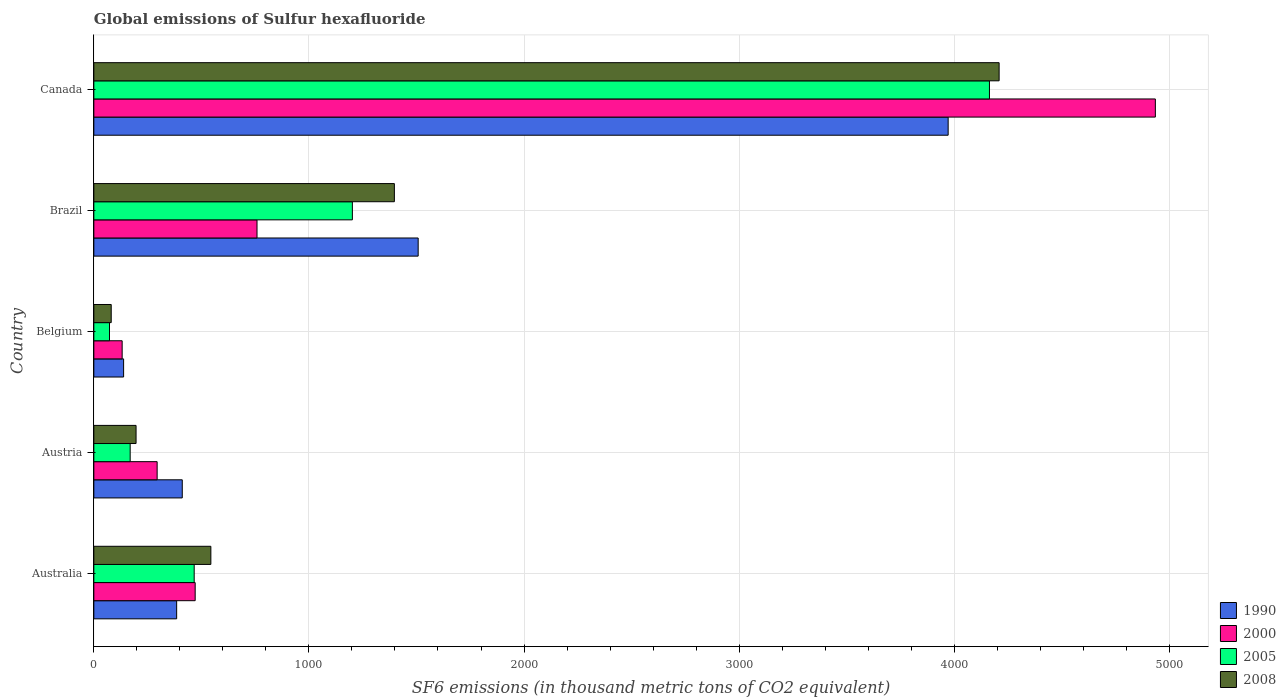Are the number of bars on each tick of the Y-axis equal?
Offer a terse response. Yes. What is the global emissions of Sulfur hexafluoride in 2008 in Brazil?
Make the answer very short. 1397.3. Across all countries, what is the maximum global emissions of Sulfur hexafluoride in 1990?
Your answer should be very brief. 3971.8. Across all countries, what is the minimum global emissions of Sulfur hexafluoride in 1990?
Give a very brief answer. 138.5. In which country was the global emissions of Sulfur hexafluoride in 2008 maximum?
Provide a short and direct response. Canada. What is the total global emissions of Sulfur hexafluoride in 2005 in the graph?
Your response must be concise. 6074.3. What is the difference between the global emissions of Sulfur hexafluoride in 2005 in Brazil and that in Canada?
Give a very brief answer. -2961.8. What is the difference between the global emissions of Sulfur hexafluoride in 2000 in Austria and the global emissions of Sulfur hexafluoride in 2005 in Australia?
Provide a succinct answer. -172.2. What is the average global emissions of Sulfur hexafluoride in 2008 per country?
Make the answer very short. 1285.5. What is the difference between the global emissions of Sulfur hexafluoride in 1990 and global emissions of Sulfur hexafluoride in 2008 in Belgium?
Provide a succinct answer. 57.6. In how many countries, is the global emissions of Sulfur hexafluoride in 2008 greater than 2400 thousand metric tons?
Provide a short and direct response. 1. What is the ratio of the global emissions of Sulfur hexafluoride in 1990 in Brazil to that in Canada?
Offer a very short reply. 0.38. What is the difference between the highest and the second highest global emissions of Sulfur hexafluoride in 2008?
Ensure brevity in your answer.  2811.5. What is the difference between the highest and the lowest global emissions of Sulfur hexafluoride in 1990?
Provide a succinct answer. 3833.3. In how many countries, is the global emissions of Sulfur hexafluoride in 2005 greater than the average global emissions of Sulfur hexafluoride in 2005 taken over all countries?
Your answer should be compact. 1. Is it the case that in every country, the sum of the global emissions of Sulfur hexafluoride in 1990 and global emissions of Sulfur hexafluoride in 2005 is greater than the sum of global emissions of Sulfur hexafluoride in 2008 and global emissions of Sulfur hexafluoride in 2000?
Give a very brief answer. No. What does the 2nd bar from the top in Austria represents?
Offer a terse response. 2005. What does the 4th bar from the bottom in Australia represents?
Keep it short and to the point. 2008. How many bars are there?
Your answer should be very brief. 20. How many countries are there in the graph?
Ensure brevity in your answer.  5. Are the values on the major ticks of X-axis written in scientific E-notation?
Your answer should be very brief. No. Does the graph contain grids?
Provide a succinct answer. Yes. How many legend labels are there?
Make the answer very short. 4. How are the legend labels stacked?
Provide a short and direct response. Vertical. What is the title of the graph?
Provide a short and direct response. Global emissions of Sulfur hexafluoride. Does "1992" appear as one of the legend labels in the graph?
Make the answer very short. No. What is the label or title of the X-axis?
Provide a succinct answer. SF6 emissions (in thousand metric tons of CO2 equivalent). What is the label or title of the Y-axis?
Your response must be concise. Country. What is the SF6 emissions (in thousand metric tons of CO2 equivalent) of 1990 in Australia?
Your response must be concise. 385.1. What is the SF6 emissions (in thousand metric tons of CO2 equivalent) of 2000 in Australia?
Offer a terse response. 471.2. What is the SF6 emissions (in thousand metric tons of CO2 equivalent) in 2005 in Australia?
Provide a short and direct response. 466.6. What is the SF6 emissions (in thousand metric tons of CO2 equivalent) of 2008 in Australia?
Make the answer very short. 544.1. What is the SF6 emissions (in thousand metric tons of CO2 equivalent) of 1990 in Austria?
Your response must be concise. 411.2. What is the SF6 emissions (in thousand metric tons of CO2 equivalent) of 2000 in Austria?
Ensure brevity in your answer.  294.4. What is the SF6 emissions (in thousand metric tons of CO2 equivalent) in 2005 in Austria?
Your response must be concise. 169. What is the SF6 emissions (in thousand metric tons of CO2 equivalent) in 2008 in Austria?
Your answer should be very brief. 196.4. What is the SF6 emissions (in thousand metric tons of CO2 equivalent) in 1990 in Belgium?
Make the answer very short. 138.5. What is the SF6 emissions (in thousand metric tons of CO2 equivalent) of 2000 in Belgium?
Ensure brevity in your answer.  131.7. What is the SF6 emissions (in thousand metric tons of CO2 equivalent) of 2005 in Belgium?
Your answer should be very brief. 72.9. What is the SF6 emissions (in thousand metric tons of CO2 equivalent) of 2008 in Belgium?
Ensure brevity in your answer.  80.9. What is the SF6 emissions (in thousand metric tons of CO2 equivalent) of 1990 in Brazil?
Provide a succinct answer. 1507.9. What is the SF6 emissions (in thousand metric tons of CO2 equivalent) of 2000 in Brazil?
Offer a terse response. 758.7. What is the SF6 emissions (in thousand metric tons of CO2 equivalent) of 2005 in Brazil?
Provide a short and direct response. 1202. What is the SF6 emissions (in thousand metric tons of CO2 equivalent) of 2008 in Brazil?
Give a very brief answer. 1397.3. What is the SF6 emissions (in thousand metric tons of CO2 equivalent) of 1990 in Canada?
Make the answer very short. 3971.8. What is the SF6 emissions (in thousand metric tons of CO2 equivalent) of 2000 in Canada?
Provide a short and direct response. 4935.1. What is the SF6 emissions (in thousand metric tons of CO2 equivalent) of 2005 in Canada?
Ensure brevity in your answer.  4163.8. What is the SF6 emissions (in thousand metric tons of CO2 equivalent) of 2008 in Canada?
Provide a succinct answer. 4208.8. Across all countries, what is the maximum SF6 emissions (in thousand metric tons of CO2 equivalent) in 1990?
Offer a very short reply. 3971.8. Across all countries, what is the maximum SF6 emissions (in thousand metric tons of CO2 equivalent) of 2000?
Offer a very short reply. 4935.1. Across all countries, what is the maximum SF6 emissions (in thousand metric tons of CO2 equivalent) in 2005?
Keep it short and to the point. 4163.8. Across all countries, what is the maximum SF6 emissions (in thousand metric tons of CO2 equivalent) in 2008?
Ensure brevity in your answer.  4208.8. Across all countries, what is the minimum SF6 emissions (in thousand metric tons of CO2 equivalent) of 1990?
Provide a short and direct response. 138.5. Across all countries, what is the minimum SF6 emissions (in thousand metric tons of CO2 equivalent) in 2000?
Make the answer very short. 131.7. Across all countries, what is the minimum SF6 emissions (in thousand metric tons of CO2 equivalent) in 2005?
Give a very brief answer. 72.9. Across all countries, what is the minimum SF6 emissions (in thousand metric tons of CO2 equivalent) in 2008?
Your answer should be very brief. 80.9. What is the total SF6 emissions (in thousand metric tons of CO2 equivalent) in 1990 in the graph?
Keep it short and to the point. 6414.5. What is the total SF6 emissions (in thousand metric tons of CO2 equivalent) of 2000 in the graph?
Your answer should be compact. 6591.1. What is the total SF6 emissions (in thousand metric tons of CO2 equivalent) in 2005 in the graph?
Your answer should be compact. 6074.3. What is the total SF6 emissions (in thousand metric tons of CO2 equivalent) of 2008 in the graph?
Your response must be concise. 6427.5. What is the difference between the SF6 emissions (in thousand metric tons of CO2 equivalent) in 1990 in Australia and that in Austria?
Your answer should be compact. -26.1. What is the difference between the SF6 emissions (in thousand metric tons of CO2 equivalent) in 2000 in Australia and that in Austria?
Provide a succinct answer. 176.8. What is the difference between the SF6 emissions (in thousand metric tons of CO2 equivalent) of 2005 in Australia and that in Austria?
Give a very brief answer. 297.6. What is the difference between the SF6 emissions (in thousand metric tons of CO2 equivalent) of 2008 in Australia and that in Austria?
Offer a very short reply. 347.7. What is the difference between the SF6 emissions (in thousand metric tons of CO2 equivalent) of 1990 in Australia and that in Belgium?
Your response must be concise. 246.6. What is the difference between the SF6 emissions (in thousand metric tons of CO2 equivalent) of 2000 in Australia and that in Belgium?
Offer a very short reply. 339.5. What is the difference between the SF6 emissions (in thousand metric tons of CO2 equivalent) of 2005 in Australia and that in Belgium?
Offer a terse response. 393.7. What is the difference between the SF6 emissions (in thousand metric tons of CO2 equivalent) in 2008 in Australia and that in Belgium?
Ensure brevity in your answer.  463.2. What is the difference between the SF6 emissions (in thousand metric tons of CO2 equivalent) in 1990 in Australia and that in Brazil?
Provide a short and direct response. -1122.8. What is the difference between the SF6 emissions (in thousand metric tons of CO2 equivalent) in 2000 in Australia and that in Brazil?
Make the answer very short. -287.5. What is the difference between the SF6 emissions (in thousand metric tons of CO2 equivalent) of 2005 in Australia and that in Brazil?
Keep it short and to the point. -735.4. What is the difference between the SF6 emissions (in thousand metric tons of CO2 equivalent) in 2008 in Australia and that in Brazil?
Provide a short and direct response. -853.2. What is the difference between the SF6 emissions (in thousand metric tons of CO2 equivalent) in 1990 in Australia and that in Canada?
Your response must be concise. -3586.7. What is the difference between the SF6 emissions (in thousand metric tons of CO2 equivalent) of 2000 in Australia and that in Canada?
Provide a short and direct response. -4463.9. What is the difference between the SF6 emissions (in thousand metric tons of CO2 equivalent) in 2005 in Australia and that in Canada?
Provide a succinct answer. -3697.2. What is the difference between the SF6 emissions (in thousand metric tons of CO2 equivalent) in 2008 in Australia and that in Canada?
Ensure brevity in your answer.  -3664.7. What is the difference between the SF6 emissions (in thousand metric tons of CO2 equivalent) of 1990 in Austria and that in Belgium?
Your response must be concise. 272.7. What is the difference between the SF6 emissions (in thousand metric tons of CO2 equivalent) in 2000 in Austria and that in Belgium?
Your response must be concise. 162.7. What is the difference between the SF6 emissions (in thousand metric tons of CO2 equivalent) in 2005 in Austria and that in Belgium?
Your answer should be compact. 96.1. What is the difference between the SF6 emissions (in thousand metric tons of CO2 equivalent) in 2008 in Austria and that in Belgium?
Keep it short and to the point. 115.5. What is the difference between the SF6 emissions (in thousand metric tons of CO2 equivalent) of 1990 in Austria and that in Brazil?
Your answer should be compact. -1096.7. What is the difference between the SF6 emissions (in thousand metric tons of CO2 equivalent) in 2000 in Austria and that in Brazil?
Provide a short and direct response. -464.3. What is the difference between the SF6 emissions (in thousand metric tons of CO2 equivalent) of 2005 in Austria and that in Brazil?
Give a very brief answer. -1033. What is the difference between the SF6 emissions (in thousand metric tons of CO2 equivalent) in 2008 in Austria and that in Brazil?
Offer a very short reply. -1200.9. What is the difference between the SF6 emissions (in thousand metric tons of CO2 equivalent) of 1990 in Austria and that in Canada?
Offer a very short reply. -3560.6. What is the difference between the SF6 emissions (in thousand metric tons of CO2 equivalent) in 2000 in Austria and that in Canada?
Give a very brief answer. -4640.7. What is the difference between the SF6 emissions (in thousand metric tons of CO2 equivalent) in 2005 in Austria and that in Canada?
Offer a very short reply. -3994.8. What is the difference between the SF6 emissions (in thousand metric tons of CO2 equivalent) in 2008 in Austria and that in Canada?
Your answer should be very brief. -4012.4. What is the difference between the SF6 emissions (in thousand metric tons of CO2 equivalent) in 1990 in Belgium and that in Brazil?
Offer a terse response. -1369.4. What is the difference between the SF6 emissions (in thousand metric tons of CO2 equivalent) in 2000 in Belgium and that in Brazil?
Your answer should be compact. -627. What is the difference between the SF6 emissions (in thousand metric tons of CO2 equivalent) of 2005 in Belgium and that in Brazil?
Provide a succinct answer. -1129.1. What is the difference between the SF6 emissions (in thousand metric tons of CO2 equivalent) of 2008 in Belgium and that in Brazil?
Your answer should be very brief. -1316.4. What is the difference between the SF6 emissions (in thousand metric tons of CO2 equivalent) in 1990 in Belgium and that in Canada?
Provide a short and direct response. -3833.3. What is the difference between the SF6 emissions (in thousand metric tons of CO2 equivalent) in 2000 in Belgium and that in Canada?
Offer a very short reply. -4803.4. What is the difference between the SF6 emissions (in thousand metric tons of CO2 equivalent) in 2005 in Belgium and that in Canada?
Offer a very short reply. -4090.9. What is the difference between the SF6 emissions (in thousand metric tons of CO2 equivalent) of 2008 in Belgium and that in Canada?
Your answer should be very brief. -4127.9. What is the difference between the SF6 emissions (in thousand metric tons of CO2 equivalent) in 1990 in Brazil and that in Canada?
Provide a succinct answer. -2463.9. What is the difference between the SF6 emissions (in thousand metric tons of CO2 equivalent) in 2000 in Brazil and that in Canada?
Your answer should be very brief. -4176.4. What is the difference between the SF6 emissions (in thousand metric tons of CO2 equivalent) in 2005 in Brazil and that in Canada?
Keep it short and to the point. -2961.8. What is the difference between the SF6 emissions (in thousand metric tons of CO2 equivalent) of 2008 in Brazil and that in Canada?
Your answer should be very brief. -2811.5. What is the difference between the SF6 emissions (in thousand metric tons of CO2 equivalent) of 1990 in Australia and the SF6 emissions (in thousand metric tons of CO2 equivalent) of 2000 in Austria?
Offer a terse response. 90.7. What is the difference between the SF6 emissions (in thousand metric tons of CO2 equivalent) in 1990 in Australia and the SF6 emissions (in thousand metric tons of CO2 equivalent) in 2005 in Austria?
Your answer should be very brief. 216.1. What is the difference between the SF6 emissions (in thousand metric tons of CO2 equivalent) of 1990 in Australia and the SF6 emissions (in thousand metric tons of CO2 equivalent) of 2008 in Austria?
Make the answer very short. 188.7. What is the difference between the SF6 emissions (in thousand metric tons of CO2 equivalent) in 2000 in Australia and the SF6 emissions (in thousand metric tons of CO2 equivalent) in 2005 in Austria?
Provide a short and direct response. 302.2. What is the difference between the SF6 emissions (in thousand metric tons of CO2 equivalent) in 2000 in Australia and the SF6 emissions (in thousand metric tons of CO2 equivalent) in 2008 in Austria?
Keep it short and to the point. 274.8. What is the difference between the SF6 emissions (in thousand metric tons of CO2 equivalent) of 2005 in Australia and the SF6 emissions (in thousand metric tons of CO2 equivalent) of 2008 in Austria?
Offer a very short reply. 270.2. What is the difference between the SF6 emissions (in thousand metric tons of CO2 equivalent) in 1990 in Australia and the SF6 emissions (in thousand metric tons of CO2 equivalent) in 2000 in Belgium?
Offer a terse response. 253.4. What is the difference between the SF6 emissions (in thousand metric tons of CO2 equivalent) of 1990 in Australia and the SF6 emissions (in thousand metric tons of CO2 equivalent) of 2005 in Belgium?
Your answer should be compact. 312.2. What is the difference between the SF6 emissions (in thousand metric tons of CO2 equivalent) in 1990 in Australia and the SF6 emissions (in thousand metric tons of CO2 equivalent) in 2008 in Belgium?
Your response must be concise. 304.2. What is the difference between the SF6 emissions (in thousand metric tons of CO2 equivalent) of 2000 in Australia and the SF6 emissions (in thousand metric tons of CO2 equivalent) of 2005 in Belgium?
Your answer should be compact. 398.3. What is the difference between the SF6 emissions (in thousand metric tons of CO2 equivalent) of 2000 in Australia and the SF6 emissions (in thousand metric tons of CO2 equivalent) of 2008 in Belgium?
Your answer should be very brief. 390.3. What is the difference between the SF6 emissions (in thousand metric tons of CO2 equivalent) of 2005 in Australia and the SF6 emissions (in thousand metric tons of CO2 equivalent) of 2008 in Belgium?
Provide a succinct answer. 385.7. What is the difference between the SF6 emissions (in thousand metric tons of CO2 equivalent) in 1990 in Australia and the SF6 emissions (in thousand metric tons of CO2 equivalent) in 2000 in Brazil?
Make the answer very short. -373.6. What is the difference between the SF6 emissions (in thousand metric tons of CO2 equivalent) of 1990 in Australia and the SF6 emissions (in thousand metric tons of CO2 equivalent) of 2005 in Brazil?
Offer a terse response. -816.9. What is the difference between the SF6 emissions (in thousand metric tons of CO2 equivalent) of 1990 in Australia and the SF6 emissions (in thousand metric tons of CO2 equivalent) of 2008 in Brazil?
Your response must be concise. -1012.2. What is the difference between the SF6 emissions (in thousand metric tons of CO2 equivalent) of 2000 in Australia and the SF6 emissions (in thousand metric tons of CO2 equivalent) of 2005 in Brazil?
Provide a short and direct response. -730.8. What is the difference between the SF6 emissions (in thousand metric tons of CO2 equivalent) in 2000 in Australia and the SF6 emissions (in thousand metric tons of CO2 equivalent) in 2008 in Brazil?
Make the answer very short. -926.1. What is the difference between the SF6 emissions (in thousand metric tons of CO2 equivalent) in 2005 in Australia and the SF6 emissions (in thousand metric tons of CO2 equivalent) in 2008 in Brazil?
Your answer should be compact. -930.7. What is the difference between the SF6 emissions (in thousand metric tons of CO2 equivalent) of 1990 in Australia and the SF6 emissions (in thousand metric tons of CO2 equivalent) of 2000 in Canada?
Make the answer very short. -4550. What is the difference between the SF6 emissions (in thousand metric tons of CO2 equivalent) in 1990 in Australia and the SF6 emissions (in thousand metric tons of CO2 equivalent) in 2005 in Canada?
Ensure brevity in your answer.  -3778.7. What is the difference between the SF6 emissions (in thousand metric tons of CO2 equivalent) in 1990 in Australia and the SF6 emissions (in thousand metric tons of CO2 equivalent) in 2008 in Canada?
Give a very brief answer. -3823.7. What is the difference between the SF6 emissions (in thousand metric tons of CO2 equivalent) in 2000 in Australia and the SF6 emissions (in thousand metric tons of CO2 equivalent) in 2005 in Canada?
Offer a very short reply. -3692.6. What is the difference between the SF6 emissions (in thousand metric tons of CO2 equivalent) in 2000 in Australia and the SF6 emissions (in thousand metric tons of CO2 equivalent) in 2008 in Canada?
Keep it short and to the point. -3737.6. What is the difference between the SF6 emissions (in thousand metric tons of CO2 equivalent) of 2005 in Australia and the SF6 emissions (in thousand metric tons of CO2 equivalent) of 2008 in Canada?
Your answer should be very brief. -3742.2. What is the difference between the SF6 emissions (in thousand metric tons of CO2 equivalent) in 1990 in Austria and the SF6 emissions (in thousand metric tons of CO2 equivalent) in 2000 in Belgium?
Offer a terse response. 279.5. What is the difference between the SF6 emissions (in thousand metric tons of CO2 equivalent) of 1990 in Austria and the SF6 emissions (in thousand metric tons of CO2 equivalent) of 2005 in Belgium?
Offer a terse response. 338.3. What is the difference between the SF6 emissions (in thousand metric tons of CO2 equivalent) in 1990 in Austria and the SF6 emissions (in thousand metric tons of CO2 equivalent) in 2008 in Belgium?
Offer a terse response. 330.3. What is the difference between the SF6 emissions (in thousand metric tons of CO2 equivalent) of 2000 in Austria and the SF6 emissions (in thousand metric tons of CO2 equivalent) of 2005 in Belgium?
Your answer should be very brief. 221.5. What is the difference between the SF6 emissions (in thousand metric tons of CO2 equivalent) of 2000 in Austria and the SF6 emissions (in thousand metric tons of CO2 equivalent) of 2008 in Belgium?
Make the answer very short. 213.5. What is the difference between the SF6 emissions (in thousand metric tons of CO2 equivalent) in 2005 in Austria and the SF6 emissions (in thousand metric tons of CO2 equivalent) in 2008 in Belgium?
Your answer should be very brief. 88.1. What is the difference between the SF6 emissions (in thousand metric tons of CO2 equivalent) in 1990 in Austria and the SF6 emissions (in thousand metric tons of CO2 equivalent) in 2000 in Brazil?
Ensure brevity in your answer.  -347.5. What is the difference between the SF6 emissions (in thousand metric tons of CO2 equivalent) in 1990 in Austria and the SF6 emissions (in thousand metric tons of CO2 equivalent) in 2005 in Brazil?
Your answer should be compact. -790.8. What is the difference between the SF6 emissions (in thousand metric tons of CO2 equivalent) of 1990 in Austria and the SF6 emissions (in thousand metric tons of CO2 equivalent) of 2008 in Brazil?
Ensure brevity in your answer.  -986.1. What is the difference between the SF6 emissions (in thousand metric tons of CO2 equivalent) in 2000 in Austria and the SF6 emissions (in thousand metric tons of CO2 equivalent) in 2005 in Brazil?
Offer a very short reply. -907.6. What is the difference between the SF6 emissions (in thousand metric tons of CO2 equivalent) of 2000 in Austria and the SF6 emissions (in thousand metric tons of CO2 equivalent) of 2008 in Brazil?
Provide a short and direct response. -1102.9. What is the difference between the SF6 emissions (in thousand metric tons of CO2 equivalent) of 2005 in Austria and the SF6 emissions (in thousand metric tons of CO2 equivalent) of 2008 in Brazil?
Provide a succinct answer. -1228.3. What is the difference between the SF6 emissions (in thousand metric tons of CO2 equivalent) in 1990 in Austria and the SF6 emissions (in thousand metric tons of CO2 equivalent) in 2000 in Canada?
Give a very brief answer. -4523.9. What is the difference between the SF6 emissions (in thousand metric tons of CO2 equivalent) of 1990 in Austria and the SF6 emissions (in thousand metric tons of CO2 equivalent) of 2005 in Canada?
Your answer should be compact. -3752.6. What is the difference between the SF6 emissions (in thousand metric tons of CO2 equivalent) in 1990 in Austria and the SF6 emissions (in thousand metric tons of CO2 equivalent) in 2008 in Canada?
Provide a succinct answer. -3797.6. What is the difference between the SF6 emissions (in thousand metric tons of CO2 equivalent) of 2000 in Austria and the SF6 emissions (in thousand metric tons of CO2 equivalent) of 2005 in Canada?
Make the answer very short. -3869.4. What is the difference between the SF6 emissions (in thousand metric tons of CO2 equivalent) in 2000 in Austria and the SF6 emissions (in thousand metric tons of CO2 equivalent) in 2008 in Canada?
Give a very brief answer. -3914.4. What is the difference between the SF6 emissions (in thousand metric tons of CO2 equivalent) in 2005 in Austria and the SF6 emissions (in thousand metric tons of CO2 equivalent) in 2008 in Canada?
Keep it short and to the point. -4039.8. What is the difference between the SF6 emissions (in thousand metric tons of CO2 equivalent) of 1990 in Belgium and the SF6 emissions (in thousand metric tons of CO2 equivalent) of 2000 in Brazil?
Provide a succinct answer. -620.2. What is the difference between the SF6 emissions (in thousand metric tons of CO2 equivalent) in 1990 in Belgium and the SF6 emissions (in thousand metric tons of CO2 equivalent) in 2005 in Brazil?
Provide a short and direct response. -1063.5. What is the difference between the SF6 emissions (in thousand metric tons of CO2 equivalent) in 1990 in Belgium and the SF6 emissions (in thousand metric tons of CO2 equivalent) in 2008 in Brazil?
Make the answer very short. -1258.8. What is the difference between the SF6 emissions (in thousand metric tons of CO2 equivalent) in 2000 in Belgium and the SF6 emissions (in thousand metric tons of CO2 equivalent) in 2005 in Brazil?
Provide a short and direct response. -1070.3. What is the difference between the SF6 emissions (in thousand metric tons of CO2 equivalent) of 2000 in Belgium and the SF6 emissions (in thousand metric tons of CO2 equivalent) of 2008 in Brazil?
Ensure brevity in your answer.  -1265.6. What is the difference between the SF6 emissions (in thousand metric tons of CO2 equivalent) in 2005 in Belgium and the SF6 emissions (in thousand metric tons of CO2 equivalent) in 2008 in Brazil?
Provide a succinct answer. -1324.4. What is the difference between the SF6 emissions (in thousand metric tons of CO2 equivalent) in 1990 in Belgium and the SF6 emissions (in thousand metric tons of CO2 equivalent) in 2000 in Canada?
Give a very brief answer. -4796.6. What is the difference between the SF6 emissions (in thousand metric tons of CO2 equivalent) of 1990 in Belgium and the SF6 emissions (in thousand metric tons of CO2 equivalent) of 2005 in Canada?
Your answer should be compact. -4025.3. What is the difference between the SF6 emissions (in thousand metric tons of CO2 equivalent) of 1990 in Belgium and the SF6 emissions (in thousand metric tons of CO2 equivalent) of 2008 in Canada?
Your answer should be very brief. -4070.3. What is the difference between the SF6 emissions (in thousand metric tons of CO2 equivalent) in 2000 in Belgium and the SF6 emissions (in thousand metric tons of CO2 equivalent) in 2005 in Canada?
Give a very brief answer. -4032.1. What is the difference between the SF6 emissions (in thousand metric tons of CO2 equivalent) of 2000 in Belgium and the SF6 emissions (in thousand metric tons of CO2 equivalent) of 2008 in Canada?
Provide a short and direct response. -4077.1. What is the difference between the SF6 emissions (in thousand metric tons of CO2 equivalent) in 2005 in Belgium and the SF6 emissions (in thousand metric tons of CO2 equivalent) in 2008 in Canada?
Give a very brief answer. -4135.9. What is the difference between the SF6 emissions (in thousand metric tons of CO2 equivalent) in 1990 in Brazil and the SF6 emissions (in thousand metric tons of CO2 equivalent) in 2000 in Canada?
Offer a very short reply. -3427.2. What is the difference between the SF6 emissions (in thousand metric tons of CO2 equivalent) of 1990 in Brazil and the SF6 emissions (in thousand metric tons of CO2 equivalent) of 2005 in Canada?
Offer a very short reply. -2655.9. What is the difference between the SF6 emissions (in thousand metric tons of CO2 equivalent) of 1990 in Brazil and the SF6 emissions (in thousand metric tons of CO2 equivalent) of 2008 in Canada?
Make the answer very short. -2700.9. What is the difference between the SF6 emissions (in thousand metric tons of CO2 equivalent) in 2000 in Brazil and the SF6 emissions (in thousand metric tons of CO2 equivalent) in 2005 in Canada?
Offer a very short reply. -3405.1. What is the difference between the SF6 emissions (in thousand metric tons of CO2 equivalent) of 2000 in Brazil and the SF6 emissions (in thousand metric tons of CO2 equivalent) of 2008 in Canada?
Offer a terse response. -3450.1. What is the difference between the SF6 emissions (in thousand metric tons of CO2 equivalent) in 2005 in Brazil and the SF6 emissions (in thousand metric tons of CO2 equivalent) in 2008 in Canada?
Offer a very short reply. -3006.8. What is the average SF6 emissions (in thousand metric tons of CO2 equivalent) of 1990 per country?
Provide a short and direct response. 1282.9. What is the average SF6 emissions (in thousand metric tons of CO2 equivalent) in 2000 per country?
Your answer should be very brief. 1318.22. What is the average SF6 emissions (in thousand metric tons of CO2 equivalent) of 2005 per country?
Ensure brevity in your answer.  1214.86. What is the average SF6 emissions (in thousand metric tons of CO2 equivalent) of 2008 per country?
Provide a succinct answer. 1285.5. What is the difference between the SF6 emissions (in thousand metric tons of CO2 equivalent) of 1990 and SF6 emissions (in thousand metric tons of CO2 equivalent) of 2000 in Australia?
Ensure brevity in your answer.  -86.1. What is the difference between the SF6 emissions (in thousand metric tons of CO2 equivalent) of 1990 and SF6 emissions (in thousand metric tons of CO2 equivalent) of 2005 in Australia?
Keep it short and to the point. -81.5. What is the difference between the SF6 emissions (in thousand metric tons of CO2 equivalent) in 1990 and SF6 emissions (in thousand metric tons of CO2 equivalent) in 2008 in Australia?
Offer a terse response. -159. What is the difference between the SF6 emissions (in thousand metric tons of CO2 equivalent) of 2000 and SF6 emissions (in thousand metric tons of CO2 equivalent) of 2005 in Australia?
Your answer should be compact. 4.6. What is the difference between the SF6 emissions (in thousand metric tons of CO2 equivalent) of 2000 and SF6 emissions (in thousand metric tons of CO2 equivalent) of 2008 in Australia?
Give a very brief answer. -72.9. What is the difference between the SF6 emissions (in thousand metric tons of CO2 equivalent) of 2005 and SF6 emissions (in thousand metric tons of CO2 equivalent) of 2008 in Australia?
Ensure brevity in your answer.  -77.5. What is the difference between the SF6 emissions (in thousand metric tons of CO2 equivalent) of 1990 and SF6 emissions (in thousand metric tons of CO2 equivalent) of 2000 in Austria?
Your answer should be compact. 116.8. What is the difference between the SF6 emissions (in thousand metric tons of CO2 equivalent) in 1990 and SF6 emissions (in thousand metric tons of CO2 equivalent) in 2005 in Austria?
Your answer should be compact. 242.2. What is the difference between the SF6 emissions (in thousand metric tons of CO2 equivalent) in 1990 and SF6 emissions (in thousand metric tons of CO2 equivalent) in 2008 in Austria?
Your answer should be compact. 214.8. What is the difference between the SF6 emissions (in thousand metric tons of CO2 equivalent) in 2000 and SF6 emissions (in thousand metric tons of CO2 equivalent) in 2005 in Austria?
Offer a very short reply. 125.4. What is the difference between the SF6 emissions (in thousand metric tons of CO2 equivalent) of 2000 and SF6 emissions (in thousand metric tons of CO2 equivalent) of 2008 in Austria?
Your response must be concise. 98. What is the difference between the SF6 emissions (in thousand metric tons of CO2 equivalent) of 2005 and SF6 emissions (in thousand metric tons of CO2 equivalent) of 2008 in Austria?
Provide a succinct answer. -27.4. What is the difference between the SF6 emissions (in thousand metric tons of CO2 equivalent) in 1990 and SF6 emissions (in thousand metric tons of CO2 equivalent) in 2000 in Belgium?
Offer a very short reply. 6.8. What is the difference between the SF6 emissions (in thousand metric tons of CO2 equivalent) of 1990 and SF6 emissions (in thousand metric tons of CO2 equivalent) of 2005 in Belgium?
Your answer should be compact. 65.6. What is the difference between the SF6 emissions (in thousand metric tons of CO2 equivalent) of 1990 and SF6 emissions (in thousand metric tons of CO2 equivalent) of 2008 in Belgium?
Your response must be concise. 57.6. What is the difference between the SF6 emissions (in thousand metric tons of CO2 equivalent) in 2000 and SF6 emissions (in thousand metric tons of CO2 equivalent) in 2005 in Belgium?
Your answer should be very brief. 58.8. What is the difference between the SF6 emissions (in thousand metric tons of CO2 equivalent) in 2000 and SF6 emissions (in thousand metric tons of CO2 equivalent) in 2008 in Belgium?
Your answer should be compact. 50.8. What is the difference between the SF6 emissions (in thousand metric tons of CO2 equivalent) of 2005 and SF6 emissions (in thousand metric tons of CO2 equivalent) of 2008 in Belgium?
Provide a succinct answer. -8. What is the difference between the SF6 emissions (in thousand metric tons of CO2 equivalent) in 1990 and SF6 emissions (in thousand metric tons of CO2 equivalent) in 2000 in Brazil?
Offer a terse response. 749.2. What is the difference between the SF6 emissions (in thousand metric tons of CO2 equivalent) of 1990 and SF6 emissions (in thousand metric tons of CO2 equivalent) of 2005 in Brazil?
Your response must be concise. 305.9. What is the difference between the SF6 emissions (in thousand metric tons of CO2 equivalent) of 1990 and SF6 emissions (in thousand metric tons of CO2 equivalent) of 2008 in Brazil?
Give a very brief answer. 110.6. What is the difference between the SF6 emissions (in thousand metric tons of CO2 equivalent) in 2000 and SF6 emissions (in thousand metric tons of CO2 equivalent) in 2005 in Brazil?
Your answer should be very brief. -443.3. What is the difference between the SF6 emissions (in thousand metric tons of CO2 equivalent) in 2000 and SF6 emissions (in thousand metric tons of CO2 equivalent) in 2008 in Brazil?
Offer a very short reply. -638.6. What is the difference between the SF6 emissions (in thousand metric tons of CO2 equivalent) in 2005 and SF6 emissions (in thousand metric tons of CO2 equivalent) in 2008 in Brazil?
Provide a short and direct response. -195.3. What is the difference between the SF6 emissions (in thousand metric tons of CO2 equivalent) of 1990 and SF6 emissions (in thousand metric tons of CO2 equivalent) of 2000 in Canada?
Ensure brevity in your answer.  -963.3. What is the difference between the SF6 emissions (in thousand metric tons of CO2 equivalent) in 1990 and SF6 emissions (in thousand metric tons of CO2 equivalent) in 2005 in Canada?
Offer a very short reply. -192. What is the difference between the SF6 emissions (in thousand metric tons of CO2 equivalent) of 1990 and SF6 emissions (in thousand metric tons of CO2 equivalent) of 2008 in Canada?
Provide a succinct answer. -237. What is the difference between the SF6 emissions (in thousand metric tons of CO2 equivalent) in 2000 and SF6 emissions (in thousand metric tons of CO2 equivalent) in 2005 in Canada?
Keep it short and to the point. 771.3. What is the difference between the SF6 emissions (in thousand metric tons of CO2 equivalent) of 2000 and SF6 emissions (in thousand metric tons of CO2 equivalent) of 2008 in Canada?
Keep it short and to the point. 726.3. What is the difference between the SF6 emissions (in thousand metric tons of CO2 equivalent) of 2005 and SF6 emissions (in thousand metric tons of CO2 equivalent) of 2008 in Canada?
Keep it short and to the point. -45. What is the ratio of the SF6 emissions (in thousand metric tons of CO2 equivalent) in 1990 in Australia to that in Austria?
Offer a very short reply. 0.94. What is the ratio of the SF6 emissions (in thousand metric tons of CO2 equivalent) in 2000 in Australia to that in Austria?
Ensure brevity in your answer.  1.6. What is the ratio of the SF6 emissions (in thousand metric tons of CO2 equivalent) in 2005 in Australia to that in Austria?
Your answer should be compact. 2.76. What is the ratio of the SF6 emissions (in thousand metric tons of CO2 equivalent) of 2008 in Australia to that in Austria?
Provide a succinct answer. 2.77. What is the ratio of the SF6 emissions (in thousand metric tons of CO2 equivalent) of 1990 in Australia to that in Belgium?
Ensure brevity in your answer.  2.78. What is the ratio of the SF6 emissions (in thousand metric tons of CO2 equivalent) in 2000 in Australia to that in Belgium?
Your answer should be very brief. 3.58. What is the ratio of the SF6 emissions (in thousand metric tons of CO2 equivalent) in 2005 in Australia to that in Belgium?
Provide a succinct answer. 6.4. What is the ratio of the SF6 emissions (in thousand metric tons of CO2 equivalent) of 2008 in Australia to that in Belgium?
Make the answer very short. 6.73. What is the ratio of the SF6 emissions (in thousand metric tons of CO2 equivalent) of 1990 in Australia to that in Brazil?
Ensure brevity in your answer.  0.26. What is the ratio of the SF6 emissions (in thousand metric tons of CO2 equivalent) in 2000 in Australia to that in Brazil?
Provide a short and direct response. 0.62. What is the ratio of the SF6 emissions (in thousand metric tons of CO2 equivalent) in 2005 in Australia to that in Brazil?
Offer a terse response. 0.39. What is the ratio of the SF6 emissions (in thousand metric tons of CO2 equivalent) of 2008 in Australia to that in Brazil?
Your answer should be very brief. 0.39. What is the ratio of the SF6 emissions (in thousand metric tons of CO2 equivalent) of 1990 in Australia to that in Canada?
Keep it short and to the point. 0.1. What is the ratio of the SF6 emissions (in thousand metric tons of CO2 equivalent) in 2000 in Australia to that in Canada?
Your answer should be very brief. 0.1. What is the ratio of the SF6 emissions (in thousand metric tons of CO2 equivalent) of 2005 in Australia to that in Canada?
Your answer should be compact. 0.11. What is the ratio of the SF6 emissions (in thousand metric tons of CO2 equivalent) of 2008 in Australia to that in Canada?
Provide a succinct answer. 0.13. What is the ratio of the SF6 emissions (in thousand metric tons of CO2 equivalent) in 1990 in Austria to that in Belgium?
Make the answer very short. 2.97. What is the ratio of the SF6 emissions (in thousand metric tons of CO2 equivalent) of 2000 in Austria to that in Belgium?
Your answer should be compact. 2.24. What is the ratio of the SF6 emissions (in thousand metric tons of CO2 equivalent) of 2005 in Austria to that in Belgium?
Your answer should be compact. 2.32. What is the ratio of the SF6 emissions (in thousand metric tons of CO2 equivalent) in 2008 in Austria to that in Belgium?
Provide a succinct answer. 2.43. What is the ratio of the SF6 emissions (in thousand metric tons of CO2 equivalent) of 1990 in Austria to that in Brazil?
Your answer should be compact. 0.27. What is the ratio of the SF6 emissions (in thousand metric tons of CO2 equivalent) in 2000 in Austria to that in Brazil?
Provide a succinct answer. 0.39. What is the ratio of the SF6 emissions (in thousand metric tons of CO2 equivalent) in 2005 in Austria to that in Brazil?
Provide a succinct answer. 0.14. What is the ratio of the SF6 emissions (in thousand metric tons of CO2 equivalent) of 2008 in Austria to that in Brazil?
Provide a short and direct response. 0.14. What is the ratio of the SF6 emissions (in thousand metric tons of CO2 equivalent) of 1990 in Austria to that in Canada?
Your answer should be very brief. 0.1. What is the ratio of the SF6 emissions (in thousand metric tons of CO2 equivalent) in 2000 in Austria to that in Canada?
Ensure brevity in your answer.  0.06. What is the ratio of the SF6 emissions (in thousand metric tons of CO2 equivalent) in 2005 in Austria to that in Canada?
Provide a short and direct response. 0.04. What is the ratio of the SF6 emissions (in thousand metric tons of CO2 equivalent) of 2008 in Austria to that in Canada?
Provide a succinct answer. 0.05. What is the ratio of the SF6 emissions (in thousand metric tons of CO2 equivalent) in 1990 in Belgium to that in Brazil?
Offer a terse response. 0.09. What is the ratio of the SF6 emissions (in thousand metric tons of CO2 equivalent) in 2000 in Belgium to that in Brazil?
Your answer should be very brief. 0.17. What is the ratio of the SF6 emissions (in thousand metric tons of CO2 equivalent) in 2005 in Belgium to that in Brazil?
Provide a succinct answer. 0.06. What is the ratio of the SF6 emissions (in thousand metric tons of CO2 equivalent) of 2008 in Belgium to that in Brazil?
Offer a terse response. 0.06. What is the ratio of the SF6 emissions (in thousand metric tons of CO2 equivalent) in 1990 in Belgium to that in Canada?
Give a very brief answer. 0.03. What is the ratio of the SF6 emissions (in thousand metric tons of CO2 equivalent) in 2000 in Belgium to that in Canada?
Offer a very short reply. 0.03. What is the ratio of the SF6 emissions (in thousand metric tons of CO2 equivalent) of 2005 in Belgium to that in Canada?
Provide a succinct answer. 0.02. What is the ratio of the SF6 emissions (in thousand metric tons of CO2 equivalent) of 2008 in Belgium to that in Canada?
Offer a very short reply. 0.02. What is the ratio of the SF6 emissions (in thousand metric tons of CO2 equivalent) in 1990 in Brazil to that in Canada?
Provide a succinct answer. 0.38. What is the ratio of the SF6 emissions (in thousand metric tons of CO2 equivalent) of 2000 in Brazil to that in Canada?
Your response must be concise. 0.15. What is the ratio of the SF6 emissions (in thousand metric tons of CO2 equivalent) of 2005 in Brazil to that in Canada?
Offer a very short reply. 0.29. What is the ratio of the SF6 emissions (in thousand metric tons of CO2 equivalent) in 2008 in Brazil to that in Canada?
Give a very brief answer. 0.33. What is the difference between the highest and the second highest SF6 emissions (in thousand metric tons of CO2 equivalent) in 1990?
Your answer should be compact. 2463.9. What is the difference between the highest and the second highest SF6 emissions (in thousand metric tons of CO2 equivalent) in 2000?
Give a very brief answer. 4176.4. What is the difference between the highest and the second highest SF6 emissions (in thousand metric tons of CO2 equivalent) of 2005?
Provide a short and direct response. 2961.8. What is the difference between the highest and the second highest SF6 emissions (in thousand metric tons of CO2 equivalent) of 2008?
Make the answer very short. 2811.5. What is the difference between the highest and the lowest SF6 emissions (in thousand metric tons of CO2 equivalent) of 1990?
Offer a very short reply. 3833.3. What is the difference between the highest and the lowest SF6 emissions (in thousand metric tons of CO2 equivalent) in 2000?
Keep it short and to the point. 4803.4. What is the difference between the highest and the lowest SF6 emissions (in thousand metric tons of CO2 equivalent) of 2005?
Offer a very short reply. 4090.9. What is the difference between the highest and the lowest SF6 emissions (in thousand metric tons of CO2 equivalent) in 2008?
Offer a terse response. 4127.9. 